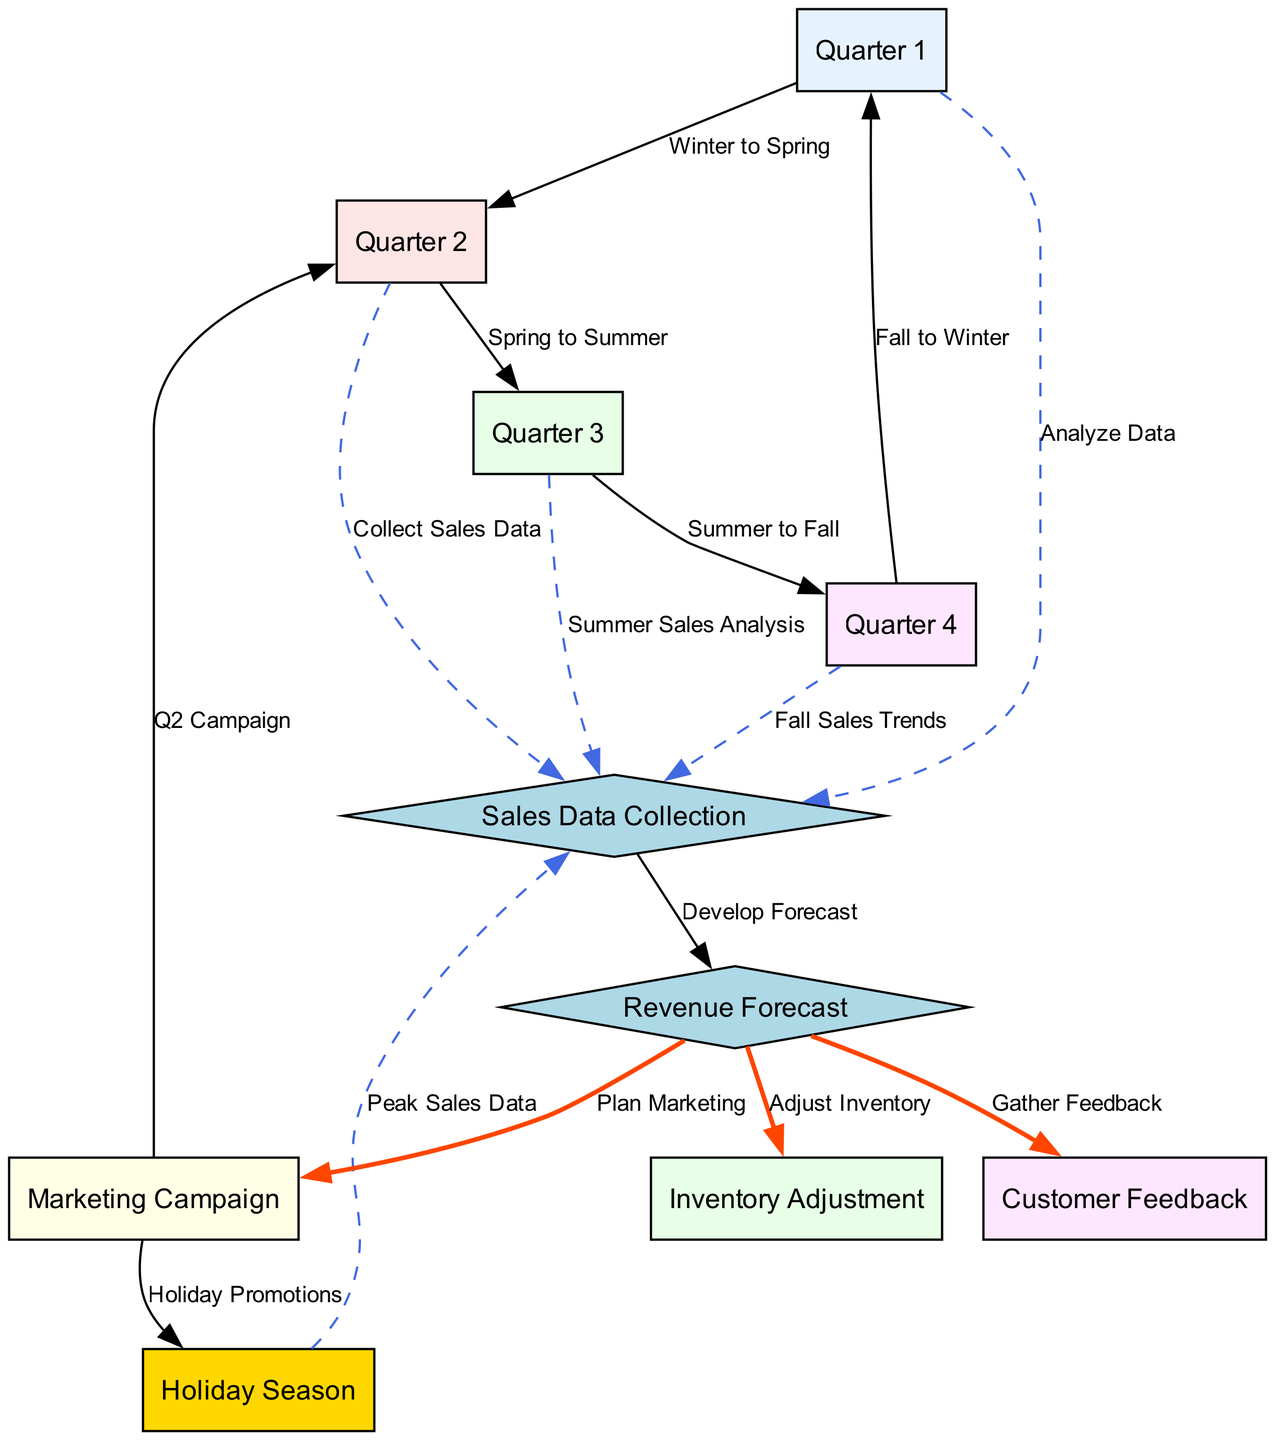What are the four quarters represented in the diagram? The diagram includes four quarters labeled as Quarter 1, Quarter 2, Quarter 3, and Quarter 4, which are connected in a cyclical manner showing seasonal trends.
Answer: Quarter 1, Quarter 2, Quarter 3, Quarter 4 What does the node for Holiday Season represent? The Holiday Season node is a peak sales period and is indicated in the diagram as a special node, denoted by distinct coloring, and it relates to sales data collection.
Answer: Peak sales period How many edges connect the Revenue Forecast node to other nodes? Analyzing the edges from the Revenue Forecast node, it shows three outgoing edges that connect it to nodes for Adjust Inventory, Gather Feedback, and Plan Marketing.
Answer: 3 Which node follows Quarter 2 in the seasonal trend? The diagram depicts a sequential flow, and following Quarter 2, which is labeled as Spring, is Quarter 3, indicating the transition to Summer.
Answer: Quarter 3 How does customer feedback relate to revenue forecasting? The diagram shows that customer feedback is gathered from the revenue forecast node, indicating that feedback is a part of post-revenue analysis and future planning.
Answer: It is gathered after revenue forecasting What is the relationship between Marketing Campaign and Holiday Promotions? The Marketing Campaign node directly leads to the Holiday Promotions node, showing that planning for marketing strategies in Q2 is crucial for Holiday season sales.
Answer: Marketing informs Holiday promotions Explain the process from Sales Data Collection to Revenue Forecast. Sales Data Collection involves multiple quarters analyzing specific sales performance, which feeds into Sales Data Collection, ultimately developing a Revenue Forecast based on this data analysis.
Answer: Analyze sales data to forecast What is the function of the Inventory Adjustment node? The Inventory Adjustment node is positioned after the Revenue Forecast node, indicating that based on forecasting, inventory levels must be adjusted accordingly.
Answer: Adjust inventory based on forecast How many nodes focus on data collection and analysis? In total, there are five nodes that emphasize data collection and analysis: Sales Data Collection, Revenue Forecast, and the four quarters that provide sales data trends.
Answer: 5 